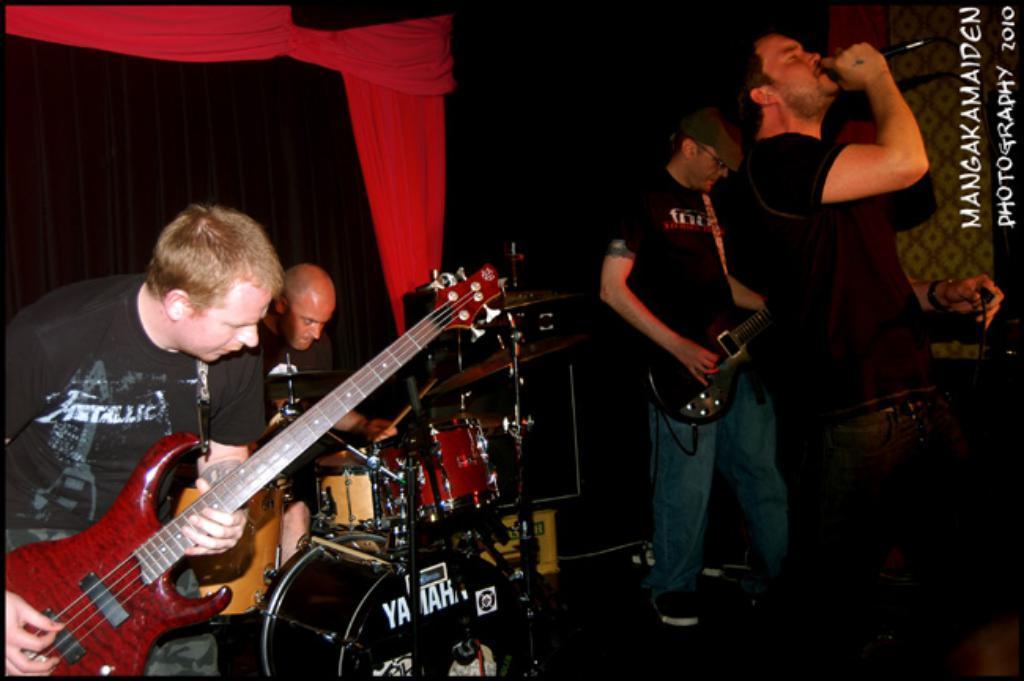Can you describe this image briefly? In this image on the right side there is one person who is standing and he is holding a mike it seems that he is singing. Beside that person there is another person who is standing and he is playing a guitar. On the left side there are two persons who are sitting, one person is playing drums and one person is playing a guitar. 